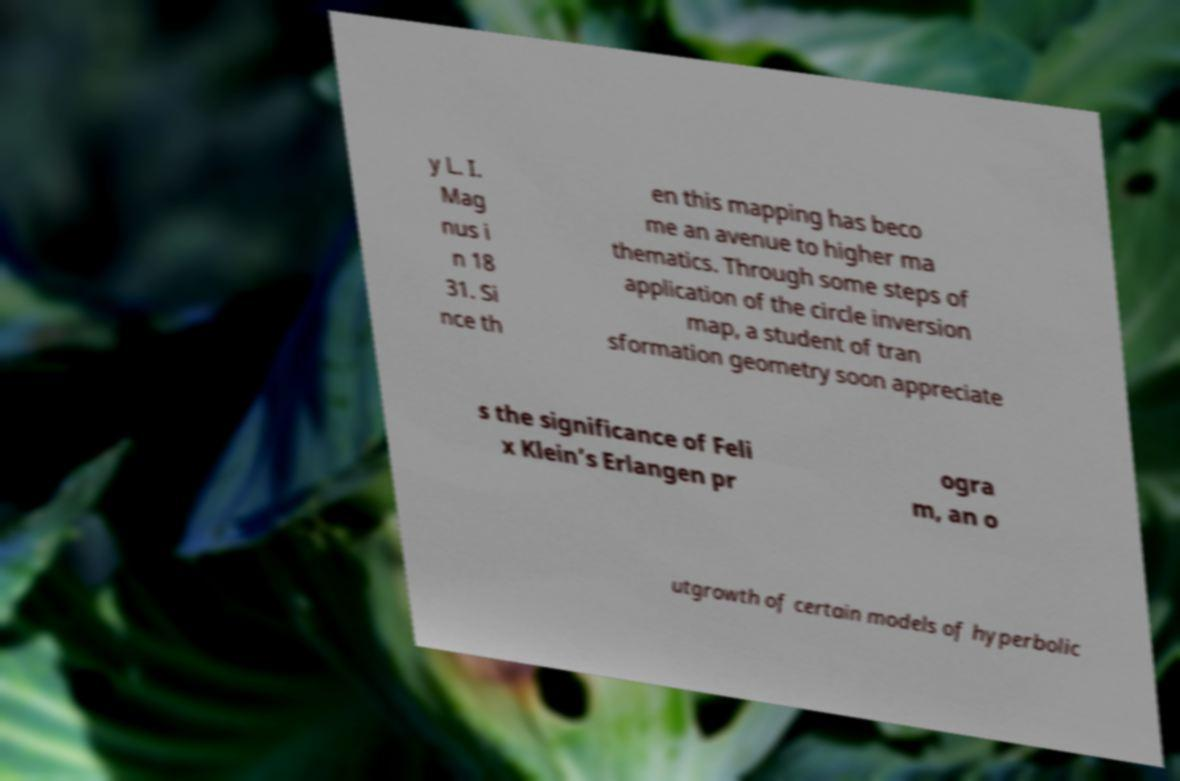Could you assist in decoding the text presented in this image and type it out clearly? y L. I. Mag nus i n 18 31. Si nce th en this mapping has beco me an avenue to higher ma thematics. Through some steps of application of the circle inversion map, a student of tran sformation geometry soon appreciate s the significance of Feli x Klein’s Erlangen pr ogra m, an o utgrowth of certain models of hyperbolic 